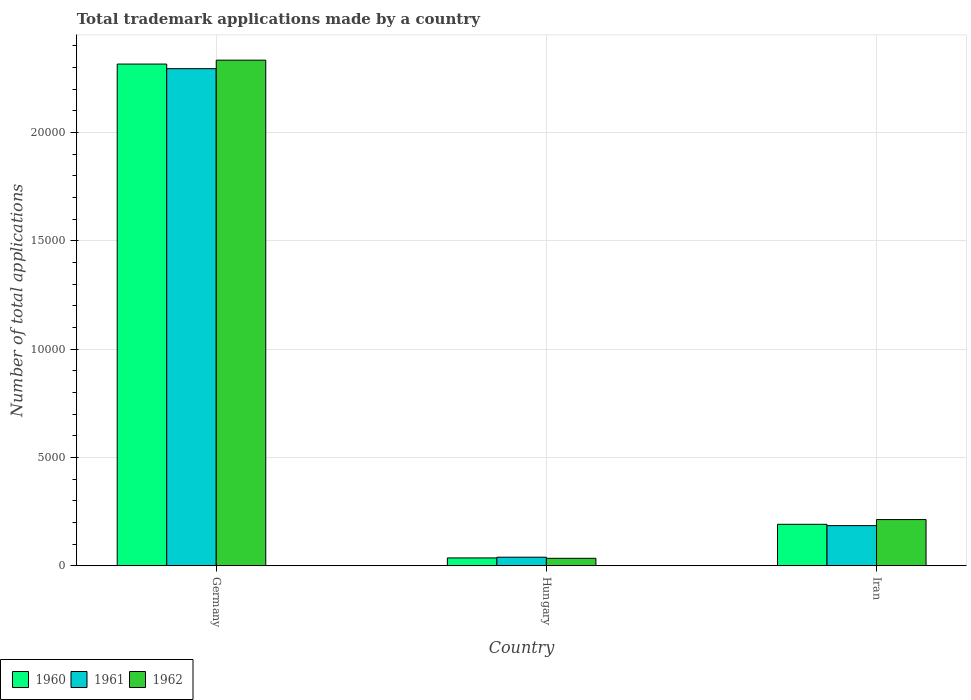How many groups of bars are there?
Provide a short and direct response. 3. How many bars are there on the 1st tick from the left?
Keep it short and to the point. 3. What is the label of the 1st group of bars from the left?
Provide a succinct answer. Germany. In how many cases, is the number of bars for a given country not equal to the number of legend labels?
Offer a very short reply. 0. What is the number of applications made by in 1962 in Iran?
Provide a succinct answer. 2134. Across all countries, what is the maximum number of applications made by in 1961?
Keep it short and to the point. 2.29e+04. Across all countries, what is the minimum number of applications made by in 1960?
Offer a terse response. 363. In which country was the number of applications made by in 1960 maximum?
Your response must be concise. Germany. In which country was the number of applications made by in 1960 minimum?
Your answer should be compact. Hungary. What is the total number of applications made by in 1960 in the graph?
Your answer should be very brief. 2.54e+04. What is the difference between the number of applications made by in 1961 in Germany and that in Iran?
Keep it short and to the point. 2.11e+04. What is the difference between the number of applications made by in 1962 in Hungary and the number of applications made by in 1960 in Iran?
Provide a short and direct response. -1569. What is the average number of applications made by in 1960 per country?
Offer a terse response. 8479.67. What is the difference between the number of applications made by of/in 1961 and number of applications made by of/in 1960 in Iran?
Your response must be concise. -61. In how many countries, is the number of applications made by in 1960 greater than 2000?
Give a very brief answer. 1. What is the ratio of the number of applications made by in 1960 in Germany to that in Hungary?
Provide a succinct answer. 63.8. Is the number of applications made by in 1962 in Germany less than that in Hungary?
Offer a terse response. No. What is the difference between the highest and the second highest number of applications made by in 1960?
Keep it short and to the point. -2.28e+04. What is the difference between the highest and the lowest number of applications made by in 1961?
Offer a very short reply. 2.26e+04. In how many countries, is the number of applications made by in 1961 greater than the average number of applications made by in 1961 taken over all countries?
Provide a succinct answer. 1. Is the sum of the number of applications made by in 1962 in Germany and Hungary greater than the maximum number of applications made by in 1960 across all countries?
Offer a very short reply. Yes. Is it the case that in every country, the sum of the number of applications made by in 1960 and number of applications made by in 1962 is greater than the number of applications made by in 1961?
Provide a short and direct response. Yes. How many bars are there?
Offer a very short reply. 9. Are all the bars in the graph horizontal?
Your answer should be very brief. No. How many countries are there in the graph?
Your answer should be compact. 3. Are the values on the major ticks of Y-axis written in scientific E-notation?
Your response must be concise. No. Does the graph contain any zero values?
Keep it short and to the point. No. Does the graph contain grids?
Provide a short and direct response. Yes. Where does the legend appear in the graph?
Provide a succinct answer. Bottom left. How are the legend labels stacked?
Offer a terse response. Horizontal. What is the title of the graph?
Provide a short and direct response. Total trademark applications made by a country. What is the label or title of the X-axis?
Provide a short and direct response. Country. What is the label or title of the Y-axis?
Your answer should be compact. Number of total applications. What is the Number of total applications in 1960 in Germany?
Ensure brevity in your answer.  2.32e+04. What is the Number of total applications in 1961 in Germany?
Give a very brief answer. 2.29e+04. What is the Number of total applications of 1962 in Germany?
Provide a succinct answer. 2.33e+04. What is the Number of total applications in 1960 in Hungary?
Your answer should be very brief. 363. What is the Number of total applications in 1961 in Hungary?
Your response must be concise. 396. What is the Number of total applications of 1962 in Hungary?
Provide a short and direct response. 346. What is the Number of total applications in 1960 in Iran?
Your answer should be very brief. 1915. What is the Number of total applications in 1961 in Iran?
Provide a succinct answer. 1854. What is the Number of total applications of 1962 in Iran?
Give a very brief answer. 2134. Across all countries, what is the maximum Number of total applications in 1960?
Provide a short and direct response. 2.32e+04. Across all countries, what is the maximum Number of total applications in 1961?
Provide a succinct answer. 2.29e+04. Across all countries, what is the maximum Number of total applications in 1962?
Your answer should be very brief. 2.33e+04. Across all countries, what is the minimum Number of total applications of 1960?
Your answer should be compact. 363. Across all countries, what is the minimum Number of total applications of 1961?
Your answer should be compact. 396. Across all countries, what is the minimum Number of total applications of 1962?
Offer a terse response. 346. What is the total Number of total applications in 1960 in the graph?
Provide a succinct answer. 2.54e+04. What is the total Number of total applications of 1961 in the graph?
Offer a very short reply. 2.52e+04. What is the total Number of total applications in 1962 in the graph?
Your answer should be compact. 2.58e+04. What is the difference between the Number of total applications of 1960 in Germany and that in Hungary?
Make the answer very short. 2.28e+04. What is the difference between the Number of total applications of 1961 in Germany and that in Hungary?
Your response must be concise. 2.26e+04. What is the difference between the Number of total applications in 1962 in Germany and that in Hungary?
Provide a short and direct response. 2.30e+04. What is the difference between the Number of total applications of 1960 in Germany and that in Iran?
Offer a terse response. 2.12e+04. What is the difference between the Number of total applications in 1961 in Germany and that in Iran?
Offer a very short reply. 2.11e+04. What is the difference between the Number of total applications in 1962 in Germany and that in Iran?
Ensure brevity in your answer.  2.12e+04. What is the difference between the Number of total applications in 1960 in Hungary and that in Iran?
Ensure brevity in your answer.  -1552. What is the difference between the Number of total applications of 1961 in Hungary and that in Iran?
Provide a succinct answer. -1458. What is the difference between the Number of total applications of 1962 in Hungary and that in Iran?
Keep it short and to the point. -1788. What is the difference between the Number of total applications of 1960 in Germany and the Number of total applications of 1961 in Hungary?
Offer a terse response. 2.28e+04. What is the difference between the Number of total applications of 1960 in Germany and the Number of total applications of 1962 in Hungary?
Make the answer very short. 2.28e+04. What is the difference between the Number of total applications of 1961 in Germany and the Number of total applications of 1962 in Hungary?
Give a very brief answer. 2.26e+04. What is the difference between the Number of total applications of 1960 in Germany and the Number of total applications of 1961 in Iran?
Provide a short and direct response. 2.13e+04. What is the difference between the Number of total applications of 1960 in Germany and the Number of total applications of 1962 in Iran?
Give a very brief answer. 2.10e+04. What is the difference between the Number of total applications of 1961 in Germany and the Number of total applications of 1962 in Iran?
Your response must be concise. 2.08e+04. What is the difference between the Number of total applications of 1960 in Hungary and the Number of total applications of 1961 in Iran?
Your response must be concise. -1491. What is the difference between the Number of total applications of 1960 in Hungary and the Number of total applications of 1962 in Iran?
Your answer should be compact. -1771. What is the difference between the Number of total applications of 1961 in Hungary and the Number of total applications of 1962 in Iran?
Give a very brief answer. -1738. What is the average Number of total applications in 1960 per country?
Provide a short and direct response. 8479.67. What is the average Number of total applications of 1961 per country?
Make the answer very short. 8399.67. What is the average Number of total applications of 1962 per country?
Offer a terse response. 8607.33. What is the difference between the Number of total applications of 1960 and Number of total applications of 1961 in Germany?
Your answer should be very brief. 212. What is the difference between the Number of total applications of 1960 and Number of total applications of 1962 in Germany?
Your answer should be compact. -181. What is the difference between the Number of total applications of 1961 and Number of total applications of 1962 in Germany?
Offer a very short reply. -393. What is the difference between the Number of total applications of 1960 and Number of total applications of 1961 in Hungary?
Keep it short and to the point. -33. What is the difference between the Number of total applications of 1960 and Number of total applications of 1962 in Hungary?
Keep it short and to the point. 17. What is the difference between the Number of total applications in 1961 and Number of total applications in 1962 in Hungary?
Make the answer very short. 50. What is the difference between the Number of total applications in 1960 and Number of total applications in 1961 in Iran?
Keep it short and to the point. 61. What is the difference between the Number of total applications of 1960 and Number of total applications of 1962 in Iran?
Offer a terse response. -219. What is the difference between the Number of total applications in 1961 and Number of total applications in 1962 in Iran?
Provide a succinct answer. -280. What is the ratio of the Number of total applications in 1960 in Germany to that in Hungary?
Provide a short and direct response. 63.8. What is the ratio of the Number of total applications in 1961 in Germany to that in Hungary?
Keep it short and to the point. 57.95. What is the ratio of the Number of total applications of 1962 in Germany to that in Hungary?
Your response must be concise. 67.46. What is the ratio of the Number of total applications in 1960 in Germany to that in Iran?
Make the answer very short. 12.09. What is the ratio of the Number of total applications of 1961 in Germany to that in Iran?
Give a very brief answer. 12.38. What is the ratio of the Number of total applications in 1962 in Germany to that in Iran?
Your response must be concise. 10.94. What is the ratio of the Number of total applications in 1960 in Hungary to that in Iran?
Provide a succinct answer. 0.19. What is the ratio of the Number of total applications in 1961 in Hungary to that in Iran?
Keep it short and to the point. 0.21. What is the ratio of the Number of total applications in 1962 in Hungary to that in Iran?
Make the answer very short. 0.16. What is the difference between the highest and the second highest Number of total applications of 1960?
Ensure brevity in your answer.  2.12e+04. What is the difference between the highest and the second highest Number of total applications in 1961?
Your answer should be compact. 2.11e+04. What is the difference between the highest and the second highest Number of total applications in 1962?
Your response must be concise. 2.12e+04. What is the difference between the highest and the lowest Number of total applications in 1960?
Provide a succinct answer. 2.28e+04. What is the difference between the highest and the lowest Number of total applications in 1961?
Your answer should be compact. 2.26e+04. What is the difference between the highest and the lowest Number of total applications in 1962?
Offer a very short reply. 2.30e+04. 